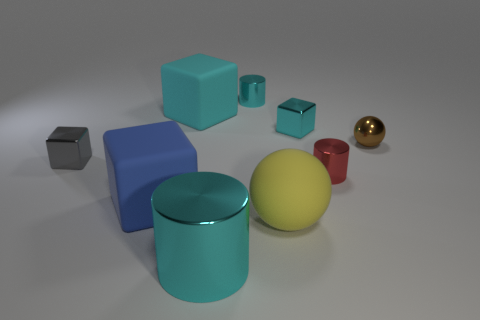There is another shiny cylinder that is the same color as the large metallic cylinder; what size is it?
Your answer should be very brief. Small. What is the material of the big object that is the same color as the large shiny cylinder?
Provide a succinct answer. Rubber. What is the size of the other rubber thing that is the same shape as the blue matte thing?
Ensure brevity in your answer.  Large. Is the color of the rubber thing that is behind the tiny gray object the same as the big metal cylinder?
Give a very brief answer. Yes. Are there fewer blue objects than large red spheres?
Make the answer very short. No. How many other things are there of the same color as the big metal cylinder?
Make the answer very short. 3. Does the cyan cylinder that is in front of the small gray shiny cube have the same material as the blue cube?
Your answer should be very brief. No. There is a cyan cylinder in front of the tiny cyan cylinder; what is its material?
Make the answer very short. Metal. What size is the cyan cube that is to the left of the large yellow sphere that is to the left of the brown sphere?
Provide a short and direct response. Large. Is there another tiny cyan ball that has the same material as the small ball?
Offer a terse response. No. 